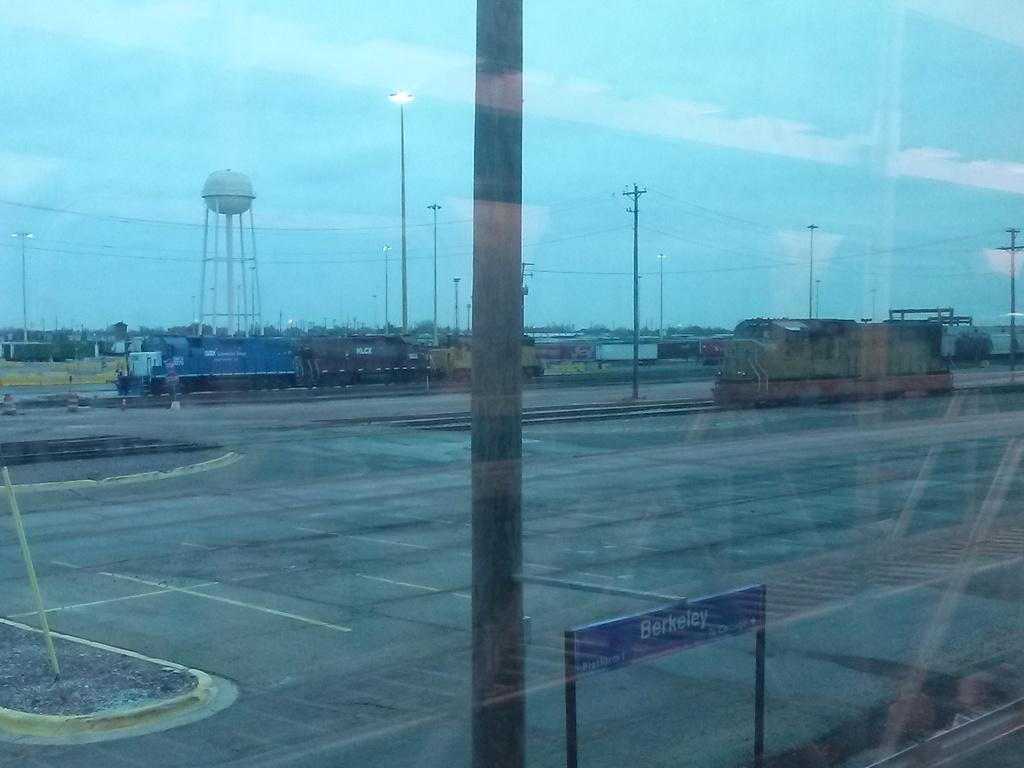<image>
Provide a brief description of the given image. The destination Berkeley is in white lettering on a blue sign 